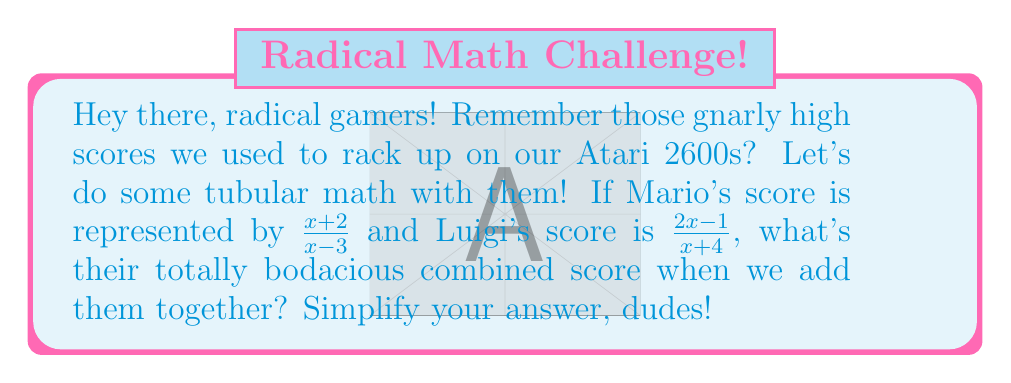Solve this math problem. Alright, let's break this down step-by-step, just like we used to do in the 80s:

1) To add rational expressions, we need a common denominator. The LCD of $(x-3)$ and $(x+4)$ is $(x-3)(x+4)$.

2) Let's multiply each fraction by the appropriate factor to get this common denominator:

   $\frac{x+2}{x-3} \cdot \frac{x+4}{x+4} + \frac{2x-1}{x+4} \cdot \frac{x-3}{x-3}$

3) This gives us:

   $\frac{(x+2)(x+4)}{(x-3)(x+4)} + \frac{(2x-1)(x-3)}{(x+4)(x-3)}$

4) Let's expand the numerators:

   $\frac{x^2+6x+8}{(x-3)(x+4)} + \frac{2x^2-7x+3}{(x+4)(x-3)}$

5) Now we can add these fractions by adding the numerators:

   $\frac{x^2+6x+8 + 2x^2-7x+3}{(x-3)(x+4)}$

6) Simplify the numerator:

   $\frac{3x^2-x+11}{(x-3)(x+4)}$

This is our simplified combined score, dudes and dudettes!
Answer: $\frac{3x^2-x+11}{(x-3)(x+4)}$ 